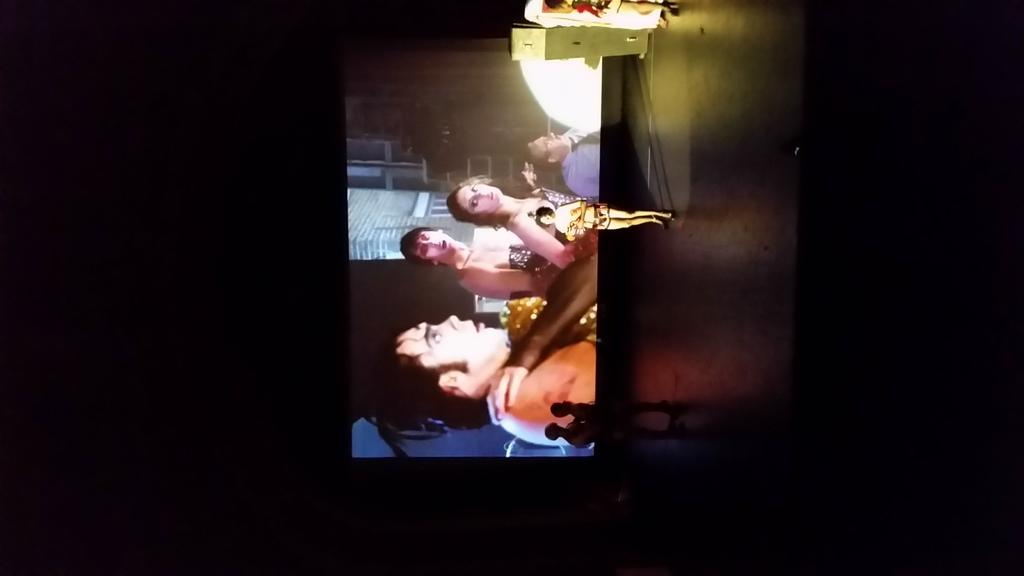How many people are on the stage in the image? There are three people standing on the stage in the image. What can be seen in the background of the image? There is a screen in the background. What is displayed on the screen? There are people visible on the screen. What type of pump can be seen in the image? There is no pump present in the image. Can you describe the sea visible in the image? There is no sea visible in the image. 